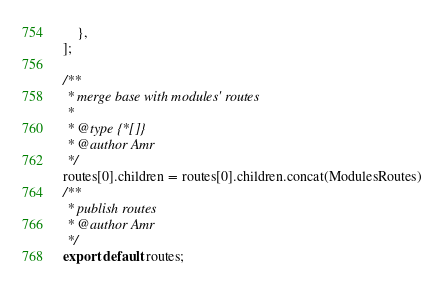<code> <loc_0><loc_0><loc_500><loc_500><_JavaScript_>    },
];

/**
 * merge base with modules' routes
 *
 * @type {*[]}
 * @author Amr
 */
routes[0].children = routes[0].children.concat(ModulesRoutes)
/**
 * publish routes
 * @author Amr
 */
export default routes;
</code> 